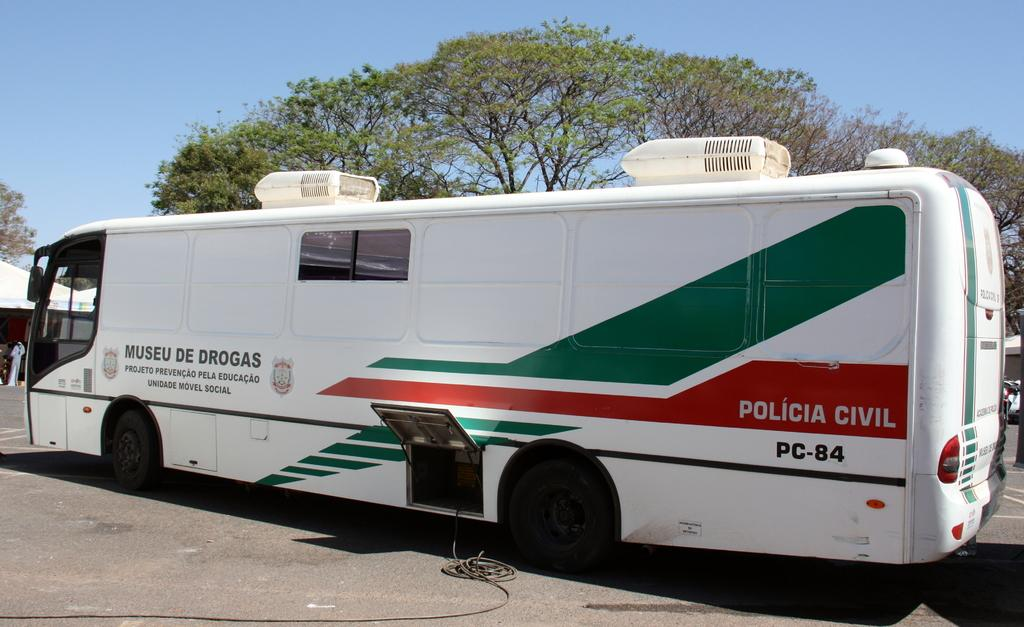<image>
Relay a brief, clear account of the picture shown. A white bus with green and red stripes says Policia Civil. 